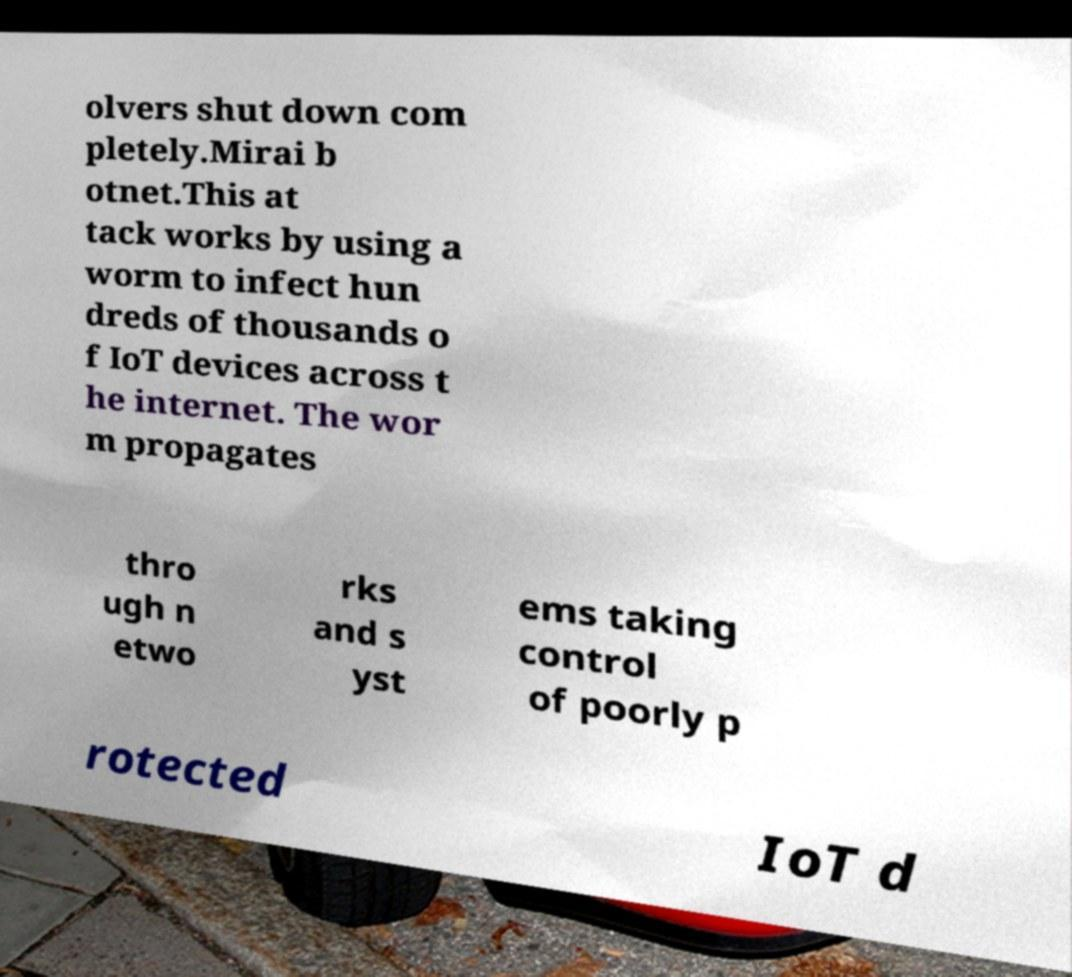There's text embedded in this image that I need extracted. Can you transcribe it verbatim? olvers shut down com pletely.Mirai b otnet.This at tack works by using a worm to infect hun dreds of thousands o f IoT devices across t he internet. The wor m propagates thro ugh n etwo rks and s yst ems taking control of poorly p rotected IoT d 